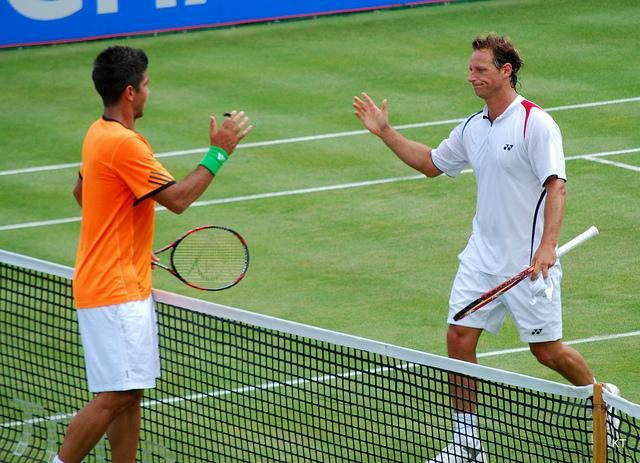What is the name of a famous player of this sport? Please explain your reasoning. sampras. Pete sampras was one of the most famous tennis players. 